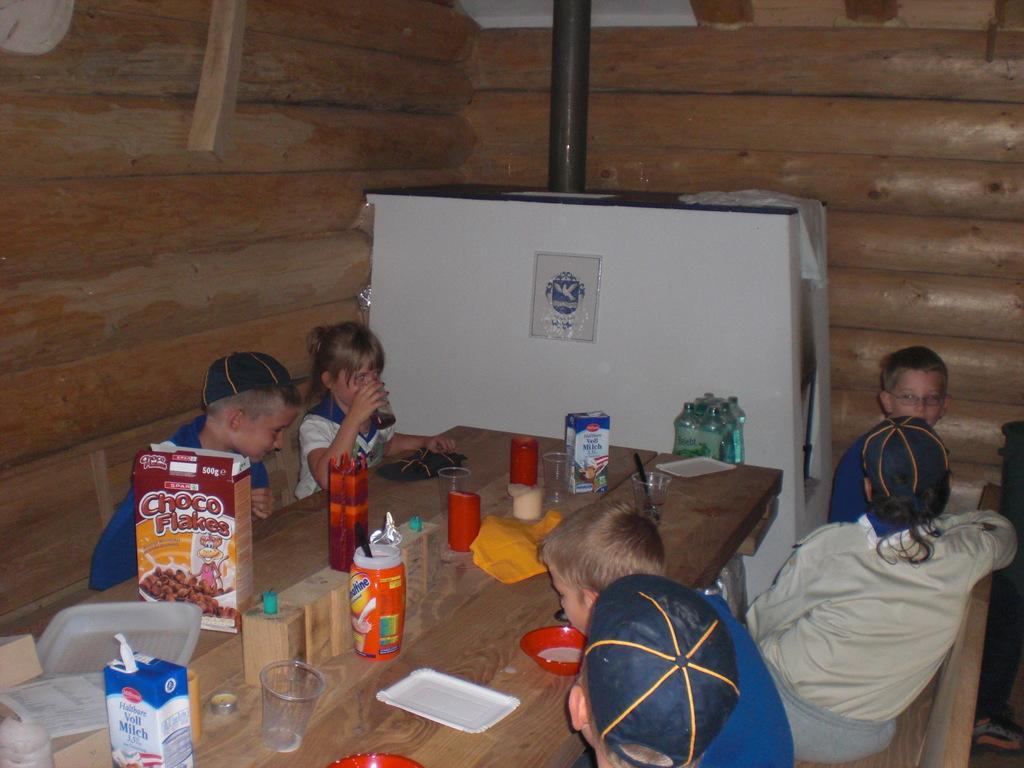Please provide a concise description of this image. In the image we can see there are kids who are sitting on the chair and in front of them there is a table on which there is a box on which it's written "Choco Flakes" and glass and tetra pack of milk. 